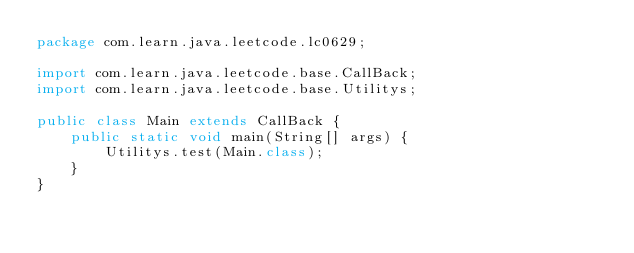Convert code to text. <code><loc_0><loc_0><loc_500><loc_500><_Java_>package com.learn.java.leetcode.lc0629;

import com.learn.java.leetcode.base.CallBack;
import com.learn.java.leetcode.base.Utilitys;

public class Main extends CallBack {
	public static void main(String[] args) {
		Utilitys.test(Main.class);
	}
}
</code> 